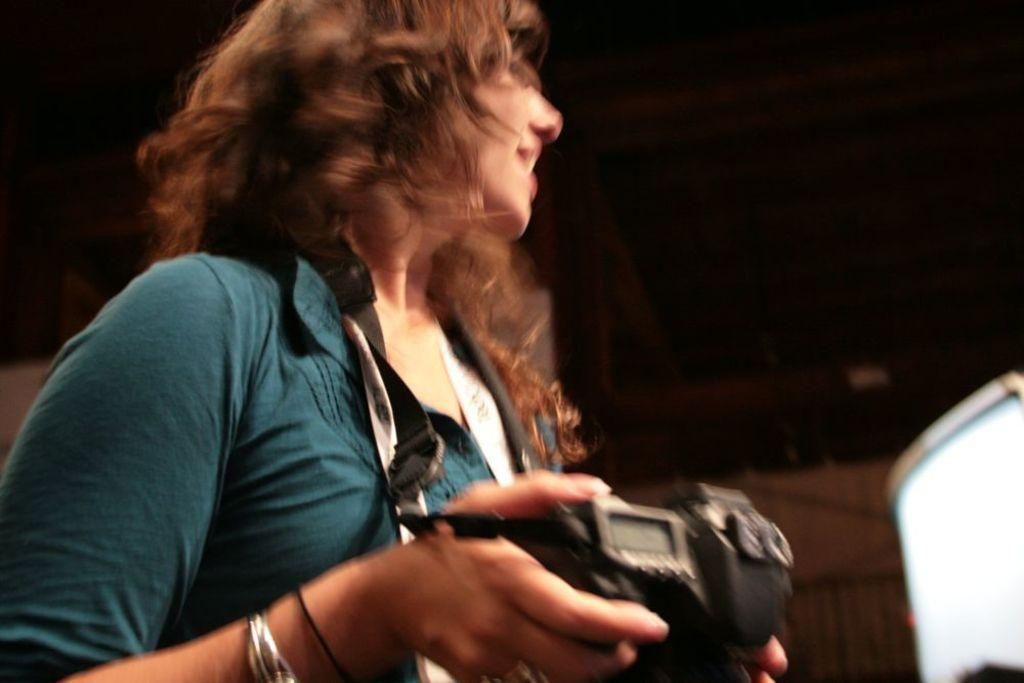Who is the main subject in the image? There is a lady in the image. What is the lady wearing? The lady is wearing a blue dress. What is the lady holding in the image? The lady is holding a camera. What expression does the lady have in the image? The lady is smiling. What type of polish is the lady applying to her nails in the image? There is no indication in the image that the lady is applying polish to her nails, and therefore no such activity can be observed. 